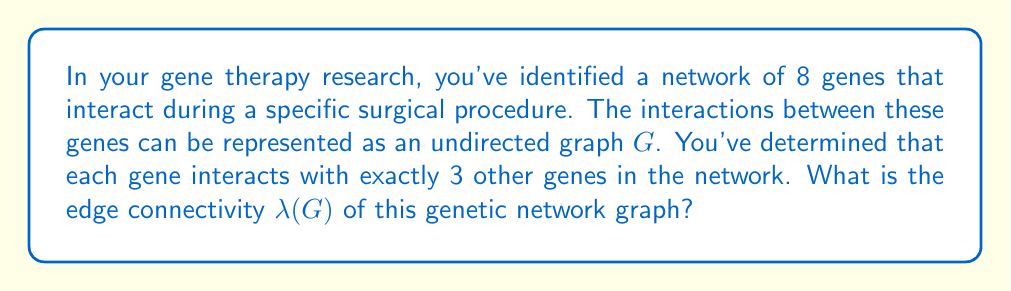Could you help me with this problem? To solve this problem, we'll use concepts from graph theory and connectivity:

1) First, let's consider the properties of the graph:
   - The graph G has 8 vertices (genes)
   - Each vertex has a degree of 3 (each gene interacts with 3 others)

2) In graph theory, the edge connectivity λ(G) is defined as the minimum number of edges that need to be removed to disconnect the graph.

3) For a k-regular graph (where each vertex has degree k), we know that:
   
   $$ λ(G) ≤ κ(G) ≤ δ(G) $$
   
   where κ(G) is the vertex connectivity and δ(G) is the minimum degree of the graph.

4) In our case, the graph is 3-regular, so δ(G) = 3.

5) For a k-regular graph that is not complete, it's known that:
   
   $$ λ(G) = κ(G) $$

6) Our graph is 3-regular and has 8 vertices. It cannot be the complete graph K₈ (which would require each vertex to have degree 7), so we can apply this property.

7) Therefore, λ(G) = κ(G) = 3

8) We can verify this intuitively: removing any 2 edges would leave the graph connected, but there exists a set of 3 edges whose removal would disconnect the graph (for example, the 3 edges connected to any single vertex).

Thus, the edge connectivity λ(G) of this genetic network graph is 3.
Answer: $λ(G) = 3$ 